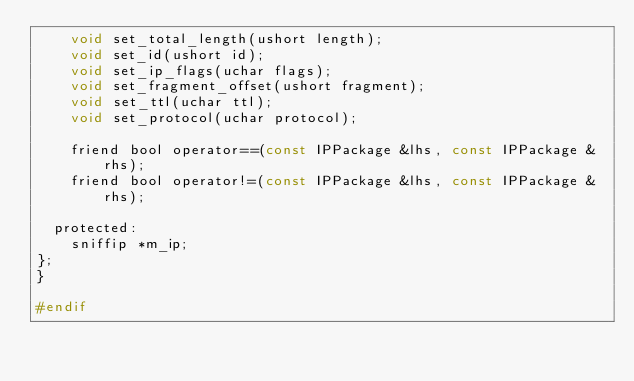<code> <loc_0><loc_0><loc_500><loc_500><_C_>    void set_total_length(ushort length);
    void set_id(ushort id);
    void set_ip_flags(uchar flags);
    void set_fragment_offset(ushort fragment);
    void set_ttl(uchar ttl);
    void set_protocol(uchar protocol);

    friend bool operator==(const IPPackage &lhs, const IPPackage &rhs);
    friend bool operator!=(const IPPackage &lhs, const IPPackage &rhs);

  protected:
    sniffip *m_ip;
};
}

#endif
</code> 